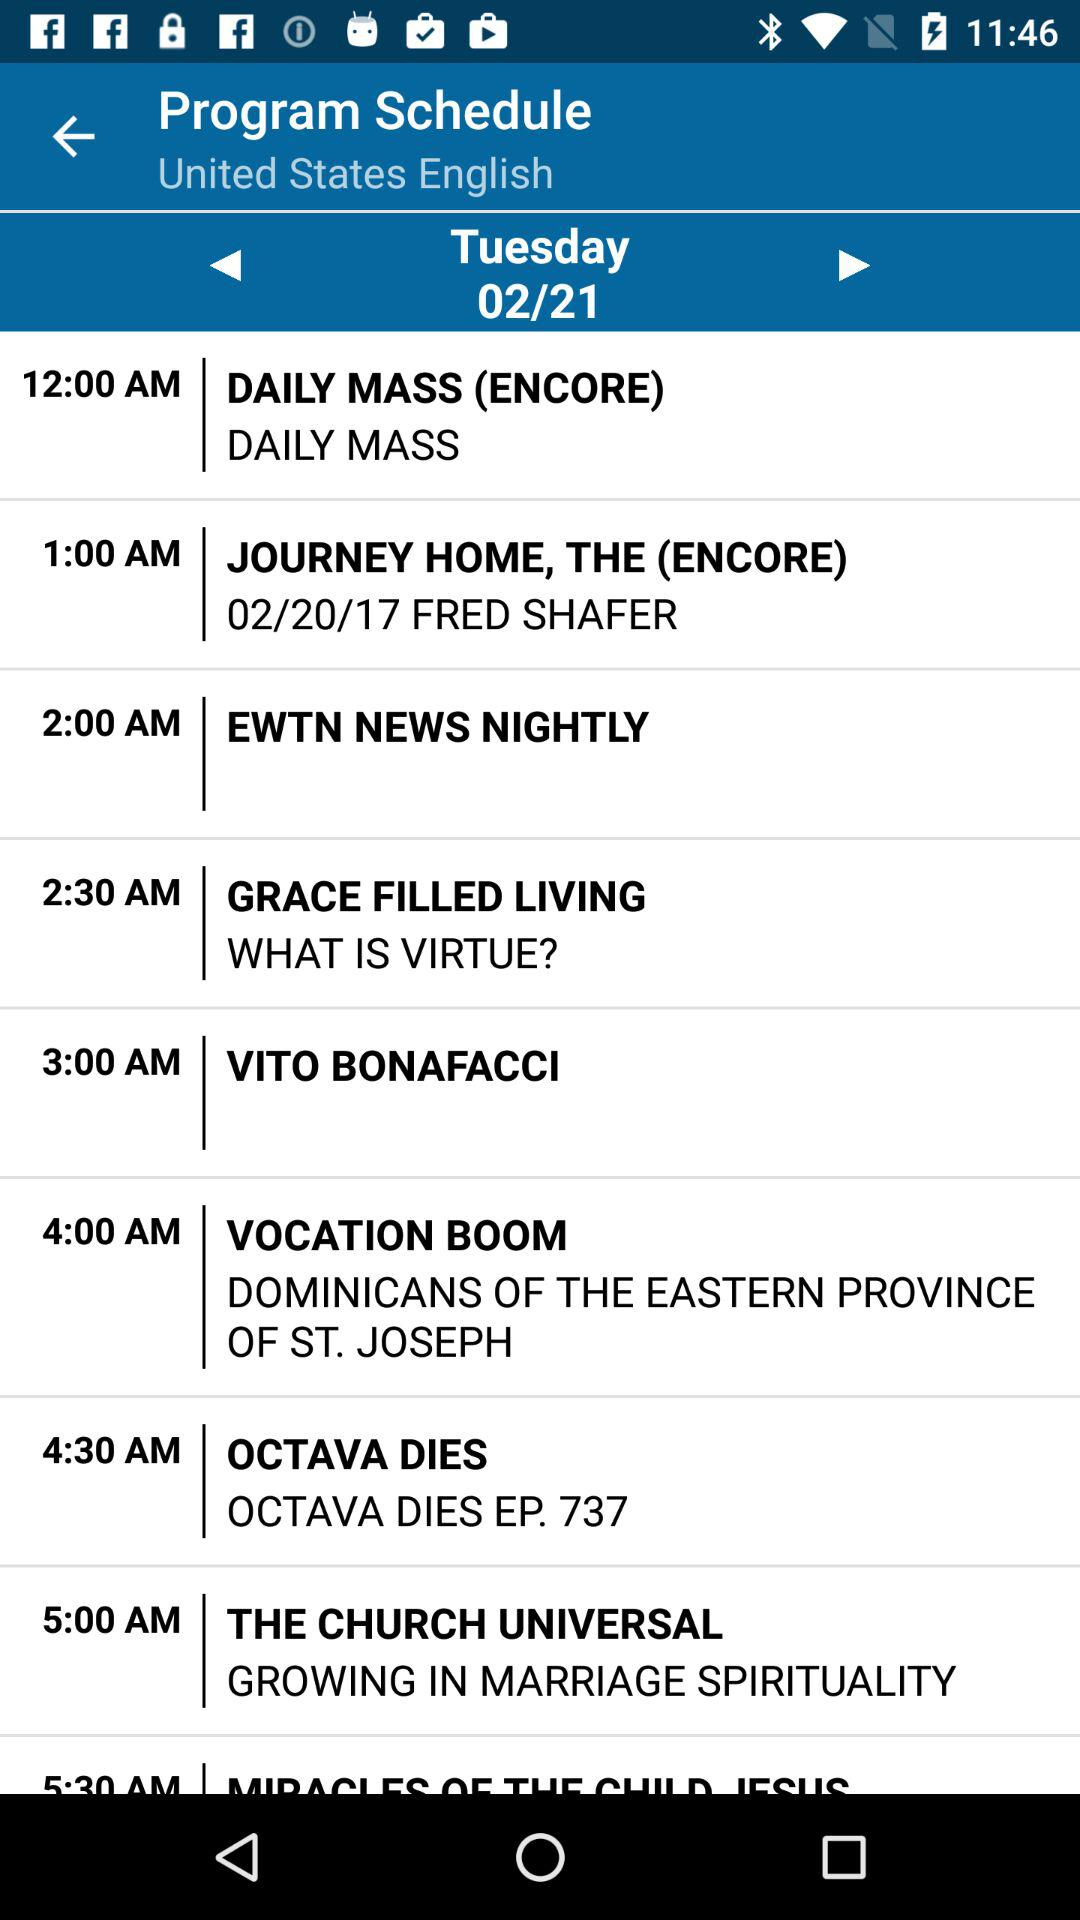Which program is scheduled for 12:00 a.m.? The scheduled program is "DAILY MASS (ENCORE)". 